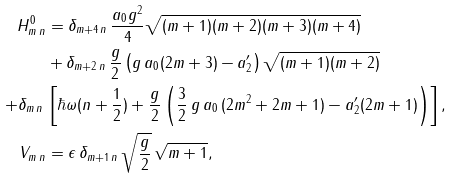Convert formula to latex. <formula><loc_0><loc_0><loc_500><loc_500>H ^ { 0 } _ { m \, n } & = \delta _ { m + 4 \, n } \, \frac { a _ { 0 } g ^ { 2 } } { 4 } \sqrt { ( m + 1 ) ( m + 2 ) ( m + 3 ) ( m + 4 ) } \\ & + \delta _ { m + 2 \, n } \, \frac { g } { 2 } \left ( g \, a _ { 0 } ( 2 m + 3 ) - a ^ { \prime } _ { 2 } \right ) \sqrt { ( m + 1 ) ( m + 2 ) } \\ + \delta _ { m \, n } \, & \left [ \hbar { \omega } ( n + \frac { 1 } { 2 } ) + \frac { g } { 2 } \left ( \frac { 3 } { 2 } \, g \, a _ { 0 } \, ( 2 m ^ { 2 } + 2 m + 1 ) - a ^ { \prime } _ { 2 } ( 2 m + 1 ) \right ) \right ] , \\ V _ { m \, n } & = \epsilon \, \delta _ { m + 1 \, n } \, \sqrt { \frac { g } { 2 } } \, \sqrt { m + 1 } ,</formula> 